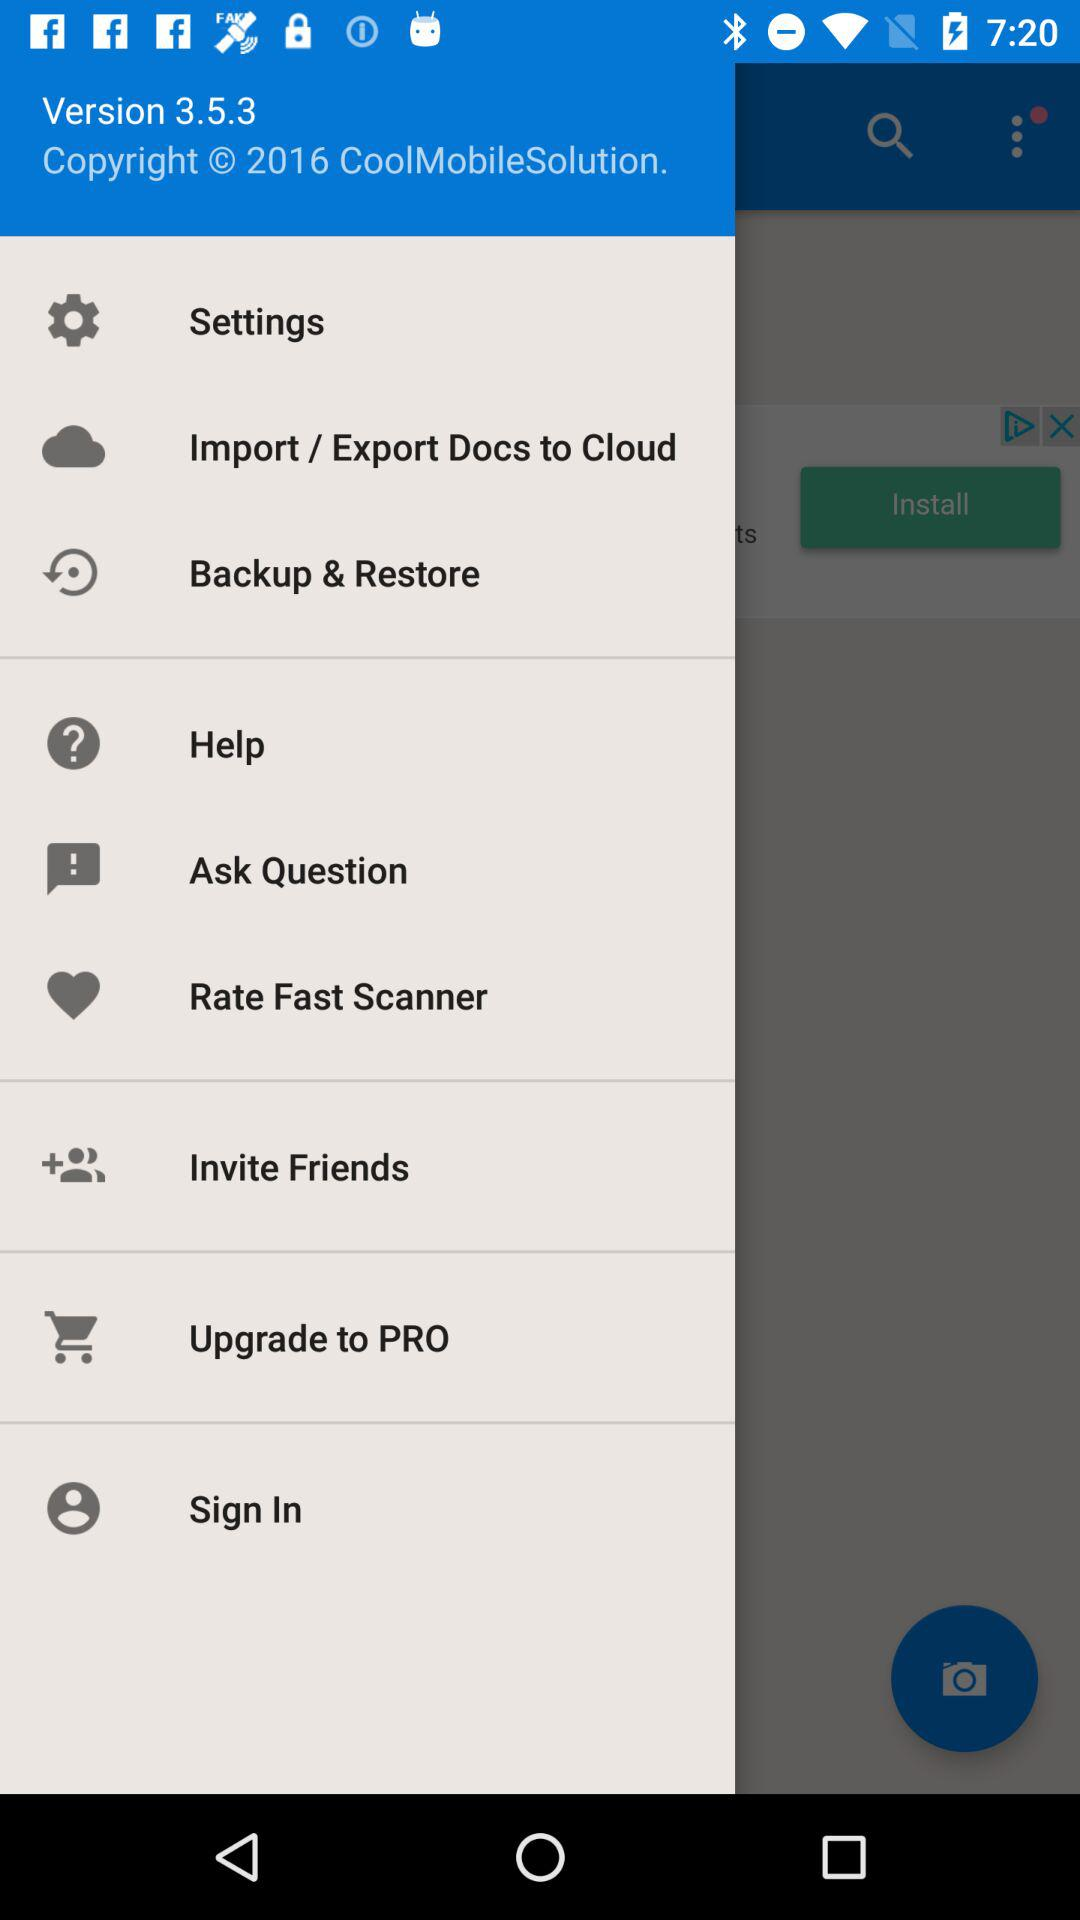What is the version? The version is 3.5.3. 